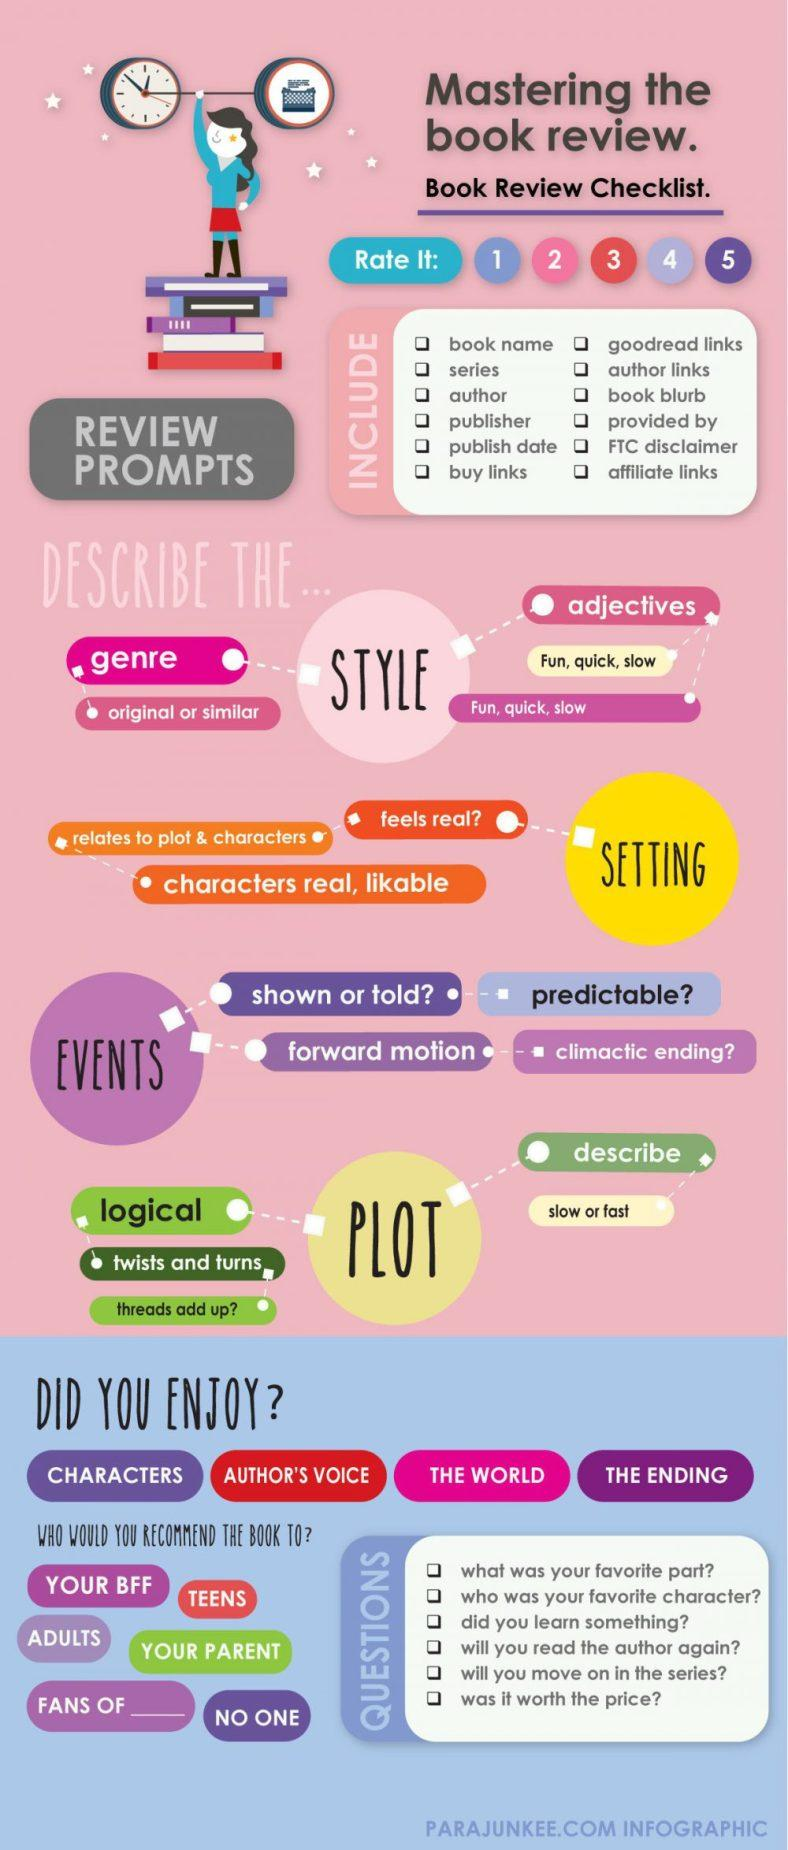Highlight a few significant elements in this photo. There are various elements to enjoy in a novel besides the characters, such as the author's voice, the world-building, and the ending. The minimum rating is 1, as it covers the lowest level of quality or performance. It is recommended that only 12 prompts should be considered in a book review. The plot speed can be described as either slow or fast. The maximum rating is 5. 